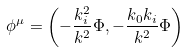<formula> <loc_0><loc_0><loc_500><loc_500>\phi ^ { \mu } = \left ( - \frac { k _ { i } ^ { 2 } } { k ^ { 2 } } \Phi , - \frac { k _ { 0 } k _ { i } } { k ^ { 2 } } \Phi \right )</formula> 